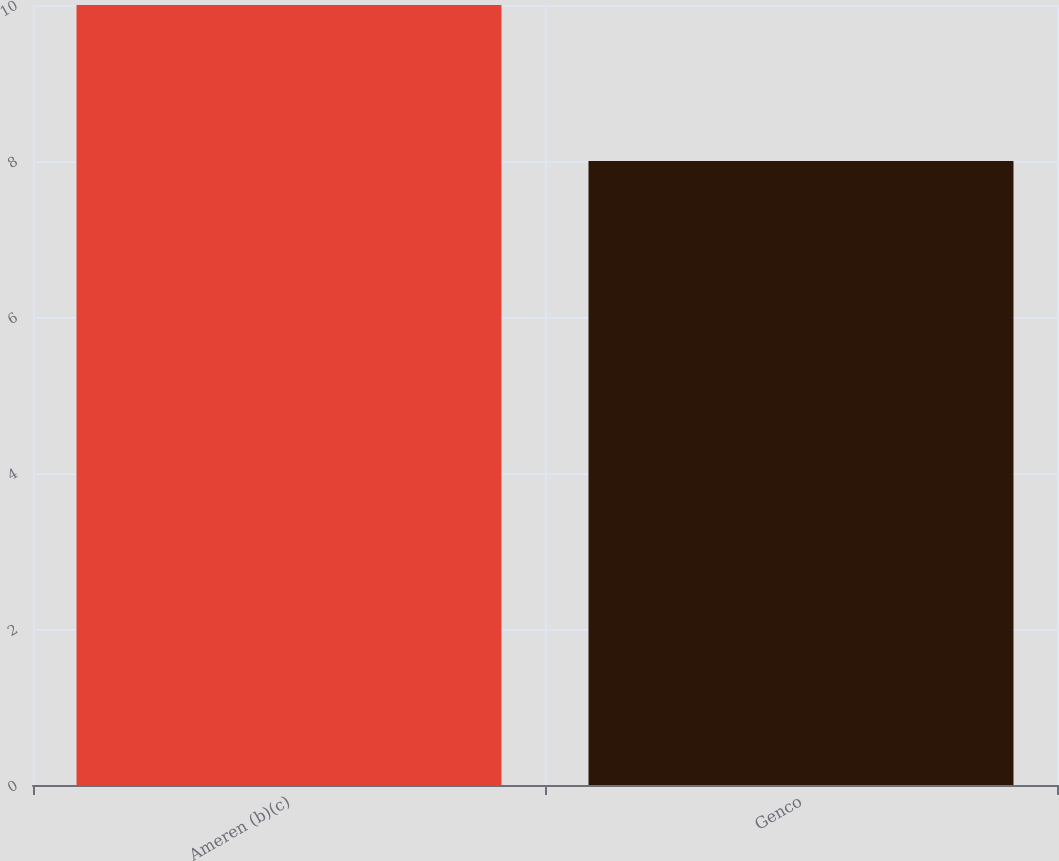Convert chart to OTSL. <chart><loc_0><loc_0><loc_500><loc_500><bar_chart><fcel>Ameren (b)(c)<fcel>Genco<nl><fcel>10<fcel>8<nl></chart> 